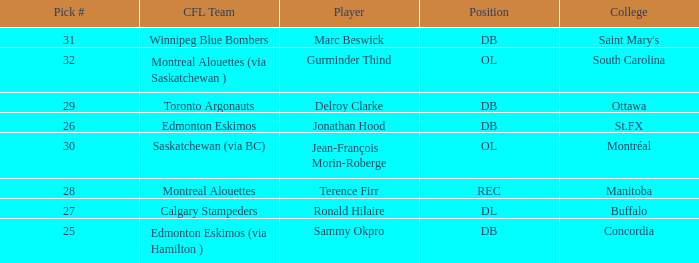Which College has a Pick # larger than 30, and a Position of ol? South Carolina. Can you give me this table as a dict? {'header': ['Pick #', 'CFL Team', 'Player', 'Position', 'College'], 'rows': [['31', 'Winnipeg Blue Bombers', 'Marc Beswick', 'DB', "Saint Mary's"], ['32', 'Montreal Alouettes (via Saskatchewan )', 'Gurminder Thind', 'OL', 'South Carolina'], ['29', 'Toronto Argonauts', 'Delroy Clarke', 'DB', 'Ottawa'], ['26', 'Edmonton Eskimos', 'Jonathan Hood', 'DB', 'St.FX'], ['30', 'Saskatchewan (via BC)', 'Jean-François Morin-Roberge', 'OL', 'Montréal'], ['28', 'Montreal Alouettes', 'Terence Firr', 'REC', 'Manitoba'], ['27', 'Calgary Stampeders', 'Ronald Hilaire', 'DL', 'Buffalo'], ['25', 'Edmonton Eskimos (via Hamilton )', 'Sammy Okpro', 'DB', 'Concordia']]} 